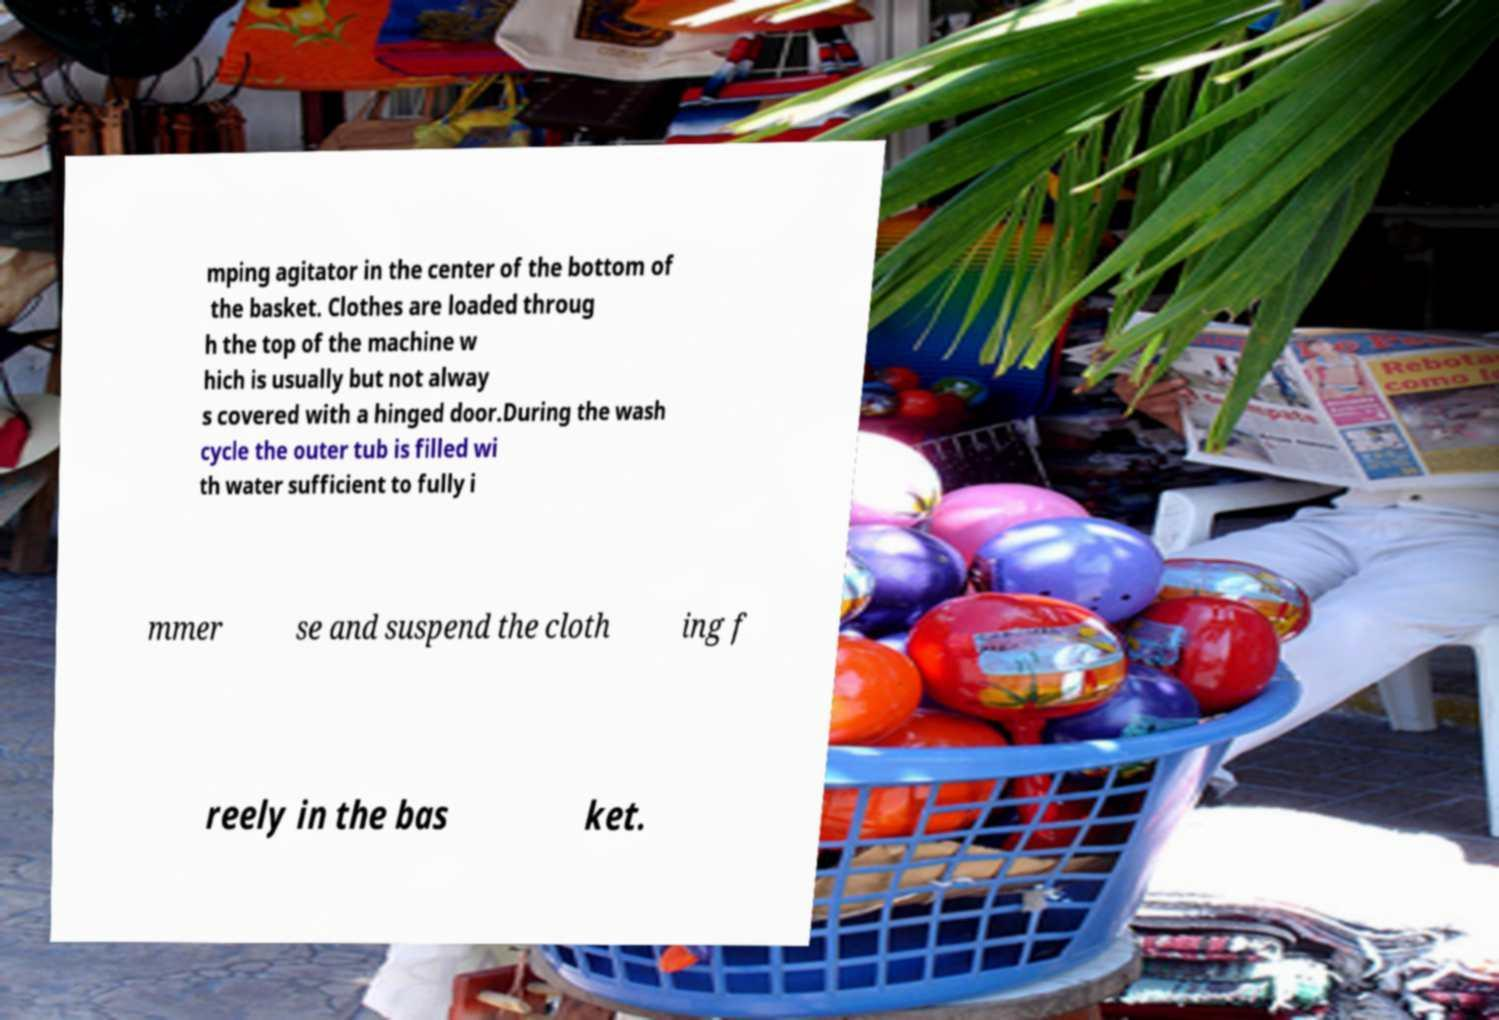Could you assist in decoding the text presented in this image and type it out clearly? mping agitator in the center of the bottom of the basket. Clothes are loaded throug h the top of the machine w hich is usually but not alway s covered with a hinged door.During the wash cycle the outer tub is filled wi th water sufficient to fully i mmer se and suspend the cloth ing f reely in the bas ket. 